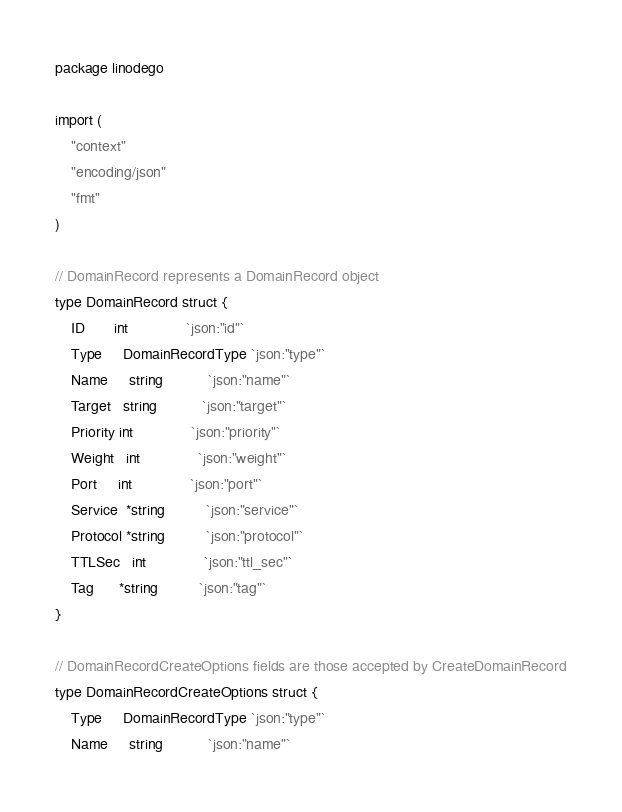<code> <loc_0><loc_0><loc_500><loc_500><_Go_>package linodego

import (
	"context"
	"encoding/json"
	"fmt"
)

// DomainRecord represents a DomainRecord object
type DomainRecord struct {
	ID       int              `json:"id"`
	Type     DomainRecordType `json:"type"`
	Name     string           `json:"name"`
	Target   string           `json:"target"`
	Priority int              `json:"priority"`
	Weight   int              `json:"weight"`
	Port     int              `json:"port"`
	Service  *string          `json:"service"`
	Protocol *string          `json:"protocol"`
	TTLSec   int              `json:"ttl_sec"`
	Tag      *string          `json:"tag"`
}

// DomainRecordCreateOptions fields are those accepted by CreateDomainRecord
type DomainRecordCreateOptions struct {
	Type     DomainRecordType `json:"type"`
	Name     string           `json:"name"`</code> 